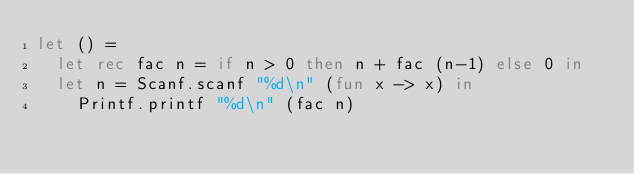<code> <loc_0><loc_0><loc_500><loc_500><_OCaml_>let () =
	let rec fac n = if n > 0 then n + fac (n-1) else 0 in
	let n = Scanf.scanf "%d\n" (fun x -> x) in
    Printf.printf "%d\n" (fac n)</code> 